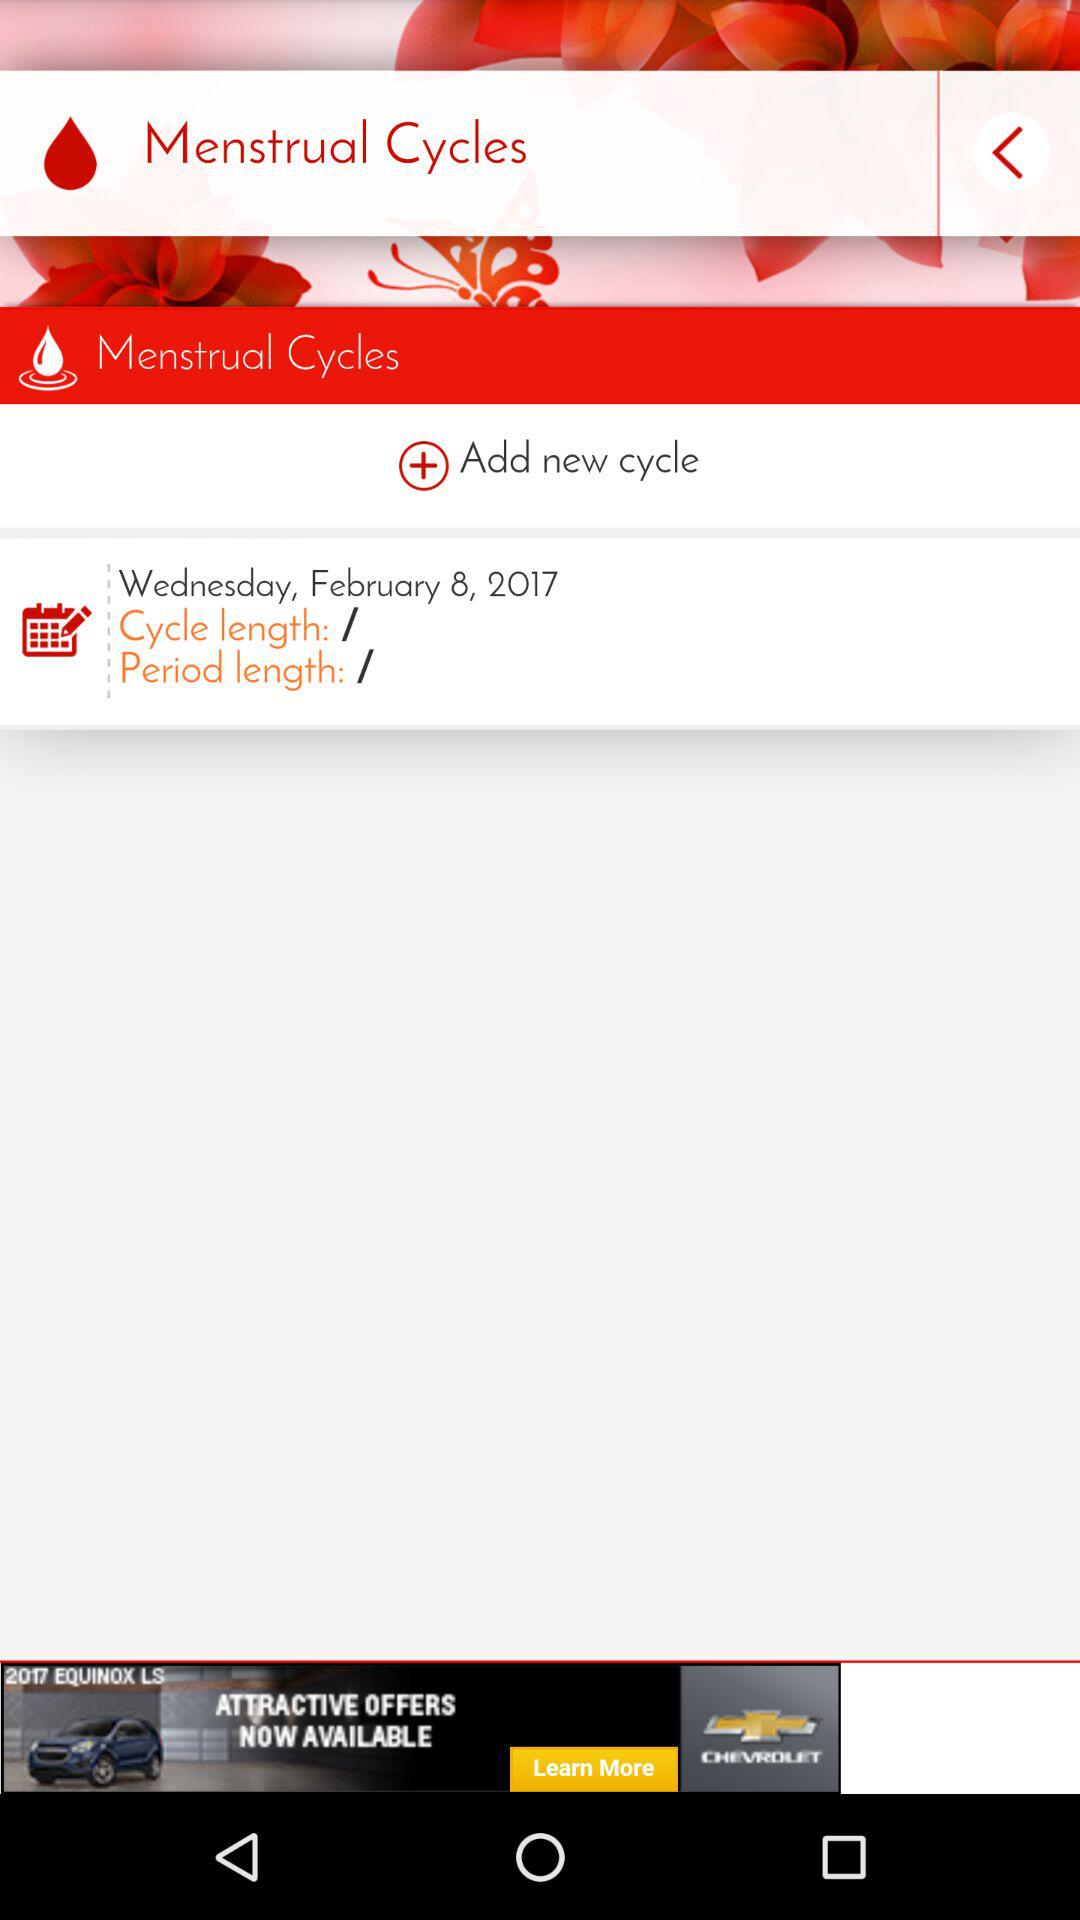What is the name of the application?
When the provided information is insufficient, respond with <no answer>. <no answer> 